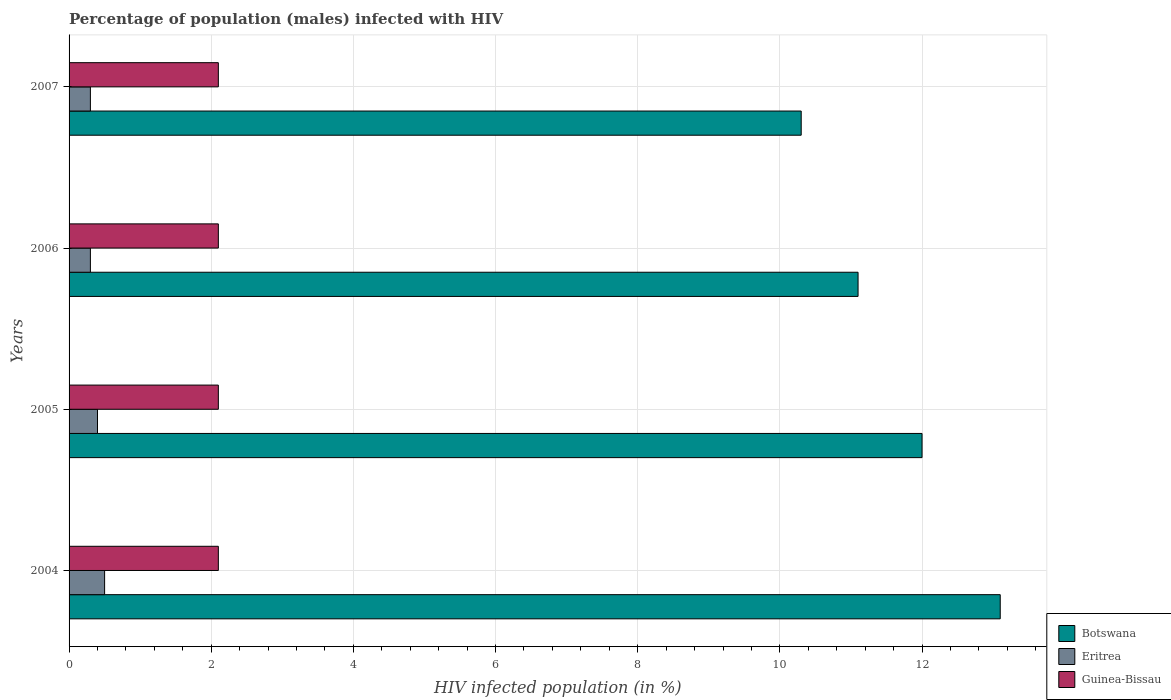How many groups of bars are there?
Give a very brief answer. 4. Are the number of bars per tick equal to the number of legend labels?
Make the answer very short. Yes. Are the number of bars on each tick of the Y-axis equal?
Your response must be concise. Yes. How many bars are there on the 3rd tick from the bottom?
Ensure brevity in your answer.  3. In how many cases, is the number of bars for a given year not equal to the number of legend labels?
Give a very brief answer. 0. What is the difference between the percentage of HIV infected male population in Eritrea in 2004 and that in 2006?
Provide a short and direct response. 0.2. What is the average percentage of HIV infected male population in Eritrea per year?
Ensure brevity in your answer.  0.38. In the year 2007, what is the difference between the percentage of HIV infected male population in Botswana and percentage of HIV infected male population in Guinea-Bissau?
Ensure brevity in your answer.  8.2. Is the difference between the percentage of HIV infected male population in Botswana in 2004 and 2007 greater than the difference between the percentage of HIV infected male population in Guinea-Bissau in 2004 and 2007?
Provide a succinct answer. Yes. In how many years, is the percentage of HIV infected male population in Eritrea greater than the average percentage of HIV infected male population in Eritrea taken over all years?
Your response must be concise. 2. Is the sum of the percentage of HIV infected male population in Guinea-Bissau in 2005 and 2007 greater than the maximum percentage of HIV infected male population in Eritrea across all years?
Give a very brief answer. Yes. What does the 2nd bar from the top in 2006 represents?
Your answer should be very brief. Eritrea. What does the 1st bar from the bottom in 2004 represents?
Your answer should be compact. Botswana. How many bars are there?
Make the answer very short. 12. Are all the bars in the graph horizontal?
Keep it short and to the point. Yes. How many years are there in the graph?
Your answer should be compact. 4. What is the difference between two consecutive major ticks on the X-axis?
Ensure brevity in your answer.  2. Are the values on the major ticks of X-axis written in scientific E-notation?
Offer a terse response. No. Does the graph contain any zero values?
Your answer should be compact. No. Does the graph contain grids?
Provide a succinct answer. Yes. Where does the legend appear in the graph?
Offer a terse response. Bottom right. How are the legend labels stacked?
Make the answer very short. Vertical. What is the title of the graph?
Offer a terse response. Percentage of population (males) infected with HIV. What is the label or title of the X-axis?
Make the answer very short. HIV infected population (in %). What is the HIV infected population (in %) of Botswana in 2004?
Give a very brief answer. 13.1. What is the HIV infected population (in %) in Botswana in 2005?
Ensure brevity in your answer.  12. What is the HIV infected population (in %) in Guinea-Bissau in 2005?
Your response must be concise. 2.1. What is the HIV infected population (in %) in Botswana in 2006?
Your answer should be compact. 11.1. What is the HIV infected population (in %) of Eritrea in 2006?
Give a very brief answer. 0.3. What is the HIV infected population (in %) in Guinea-Bissau in 2006?
Provide a succinct answer. 2.1. What is the HIV infected population (in %) of Eritrea in 2007?
Ensure brevity in your answer.  0.3. What is the HIV infected population (in %) in Guinea-Bissau in 2007?
Your response must be concise. 2.1. What is the total HIV infected population (in %) of Botswana in the graph?
Make the answer very short. 46.5. What is the total HIV infected population (in %) in Guinea-Bissau in the graph?
Your answer should be very brief. 8.4. What is the difference between the HIV infected population (in %) in Guinea-Bissau in 2004 and that in 2005?
Keep it short and to the point. 0. What is the difference between the HIV infected population (in %) in Eritrea in 2004 and that in 2006?
Ensure brevity in your answer.  0.2. What is the difference between the HIV infected population (in %) in Guinea-Bissau in 2005 and that in 2006?
Give a very brief answer. 0. What is the difference between the HIV infected population (in %) of Botswana in 2005 and that in 2007?
Provide a succinct answer. 1.7. What is the difference between the HIV infected population (in %) of Eritrea in 2005 and that in 2007?
Your response must be concise. 0.1. What is the difference between the HIV infected population (in %) of Guinea-Bissau in 2005 and that in 2007?
Your answer should be very brief. 0. What is the difference between the HIV infected population (in %) in Botswana in 2006 and that in 2007?
Offer a terse response. 0.8. What is the difference between the HIV infected population (in %) in Eritrea in 2006 and that in 2007?
Offer a terse response. 0. What is the difference between the HIV infected population (in %) in Guinea-Bissau in 2006 and that in 2007?
Keep it short and to the point. 0. What is the difference between the HIV infected population (in %) of Botswana in 2004 and the HIV infected population (in %) of Eritrea in 2005?
Offer a terse response. 12.7. What is the difference between the HIV infected population (in %) in Botswana in 2004 and the HIV infected population (in %) in Guinea-Bissau in 2005?
Offer a very short reply. 11. What is the difference between the HIV infected population (in %) in Botswana in 2004 and the HIV infected population (in %) in Guinea-Bissau in 2006?
Provide a succinct answer. 11. What is the difference between the HIV infected population (in %) of Eritrea in 2004 and the HIV infected population (in %) of Guinea-Bissau in 2006?
Offer a terse response. -1.6. What is the difference between the HIV infected population (in %) in Botswana in 2004 and the HIV infected population (in %) in Eritrea in 2007?
Provide a short and direct response. 12.8. What is the difference between the HIV infected population (in %) of Eritrea in 2004 and the HIV infected population (in %) of Guinea-Bissau in 2007?
Offer a terse response. -1.6. What is the difference between the HIV infected population (in %) of Botswana in 2005 and the HIV infected population (in %) of Eritrea in 2006?
Make the answer very short. 11.7. What is the difference between the HIV infected population (in %) of Botswana in 2005 and the HIV infected population (in %) of Guinea-Bissau in 2006?
Your response must be concise. 9.9. What is the difference between the HIV infected population (in %) of Botswana in 2005 and the HIV infected population (in %) of Eritrea in 2007?
Your answer should be very brief. 11.7. What is the difference between the HIV infected population (in %) of Botswana in 2005 and the HIV infected population (in %) of Guinea-Bissau in 2007?
Your answer should be compact. 9.9. What is the difference between the HIV infected population (in %) of Eritrea in 2005 and the HIV infected population (in %) of Guinea-Bissau in 2007?
Provide a short and direct response. -1.7. What is the difference between the HIV infected population (in %) in Botswana in 2006 and the HIV infected population (in %) in Eritrea in 2007?
Offer a terse response. 10.8. What is the difference between the HIV infected population (in %) in Eritrea in 2006 and the HIV infected population (in %) in Guinea-Bissau in 2007?
Give a very brief answer. -1.8. What is the average HIV infected population (in %) in Botswana per year?
Provide a short and direct response. 11.62. In the year 2004, what is the difference between the HIV infected population (in %) in Botswana and HIV infected population (in %) in Eritrea?
Your response must be concise. 12.6. In the year 2004, what is the difference between the HIV infected population (in %) in Botswana and HIV infected population (in %) in Guinea-Bissau?
Offer a terse response. 11. In the year 2006, what is the difference between the HIV infected population (in %) of Botswana and HIV infected population (in %) of Guinea-Bissau?
Make the answer very short. 9. In the year 2007, what is the difference between the HIV infected population (in %) of Eritrea and HIV infected population (in %) of Guinea-Bissau?
Keep it short and to the point. -1.8. What is the ratio of the HIV infected population (in %) in Botswana in 2004 to that in 2005?
Provide a succinct answer. 1.09. What is the ratio of the HIV infected population (in %) of Eritrea in 2004 to that in 2005?
Offer a very short reply. 1.25. What is the ratio of the HIV infected population (in %) in Botswana in 2004 to that in 2006?
Offer a terse response. 1.18. What is the ratio of the HIV infected population (in %) in Eritrea in 2004 to that in 2006?
Give a very brief answer. 1.67. What is the ratio of the HIV infected population (in %) of Botswana in 2004 to that in 2007?
Offer a very short reply. 1.27. What is the ratio of the HIV infected population (in %) in Guinea-Bissau in 2004 to that in 2007?
Your response must be concise. 1. What is the ratio of the HIV infected population (in %) in Botswana in 2005 to that in 2006?
Provide a short and direct response. 1.08. What is the ratio of the HIV infected population (in %) of Botswana in 2005 to that in 2007?
Provide a succinct answer. 1.17. What is the ratio of the HIV infected population (in %) in Botswana in 2006 to that in 2007?
Make the answer very short. 1.08. What is the ratio of the HIV infected population (in %) of Guinea-Bissau in 2006 to that in 2007?
Make the answer very short. 1. What is the difference between the highest and the second highest HIV infected population (in %) of Eritrea?
Your answer should be very brief. 0.1. What is the difference between the highest and the lowest HIV infected population (in %) in Botswana?
Give a very brief answer. 2.8. What is the difference between the highest and the lowest HIV infected population (in %) in Guinea-Bissau?
Keep it short and to the point. 0. 